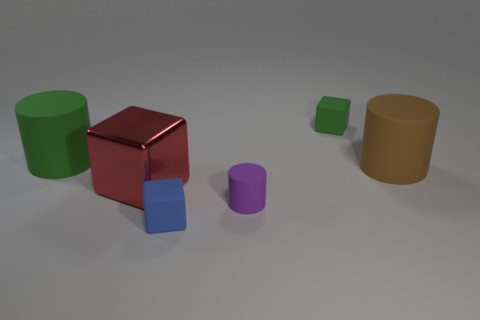What is the red block made of?
Make the answer very short. Metal. What number of brown objects are there?
Make the answer very short. 1. There is a small rubber cube that is in front of the brown rubber object; does it have the same color as the large thing that is to the left of the big metal cube?
Keep it short and to the point. No. What number of other things are there of the same size as the blue thing?
Provide a succinct answer. 2. The big rubber object that is in front of the large green thing is what color?
Ensure brevity in your answer.  Brown. Does the small green object that is on the right side of the purple object have the same material as the purple thing?
Ensure brevity in your answer.  Yes. What number of tiny matte cubes are both behind the green matte cylinder and in front of the tiny green matte cube?
Your response must be concise. 0. What color is the large matte object that is to the left of the small rubber cylinder in front of the tiny matte block on the right side of the blue matte block?
Offer a very short reply. Green. What number of other objects are the same shape as the blue object?
Make the answer very short. 2. Is there a tiny green matte thing to the left of the big cylinder on the left side of the small blue rubber object?
Your answer should be very brief. No. 